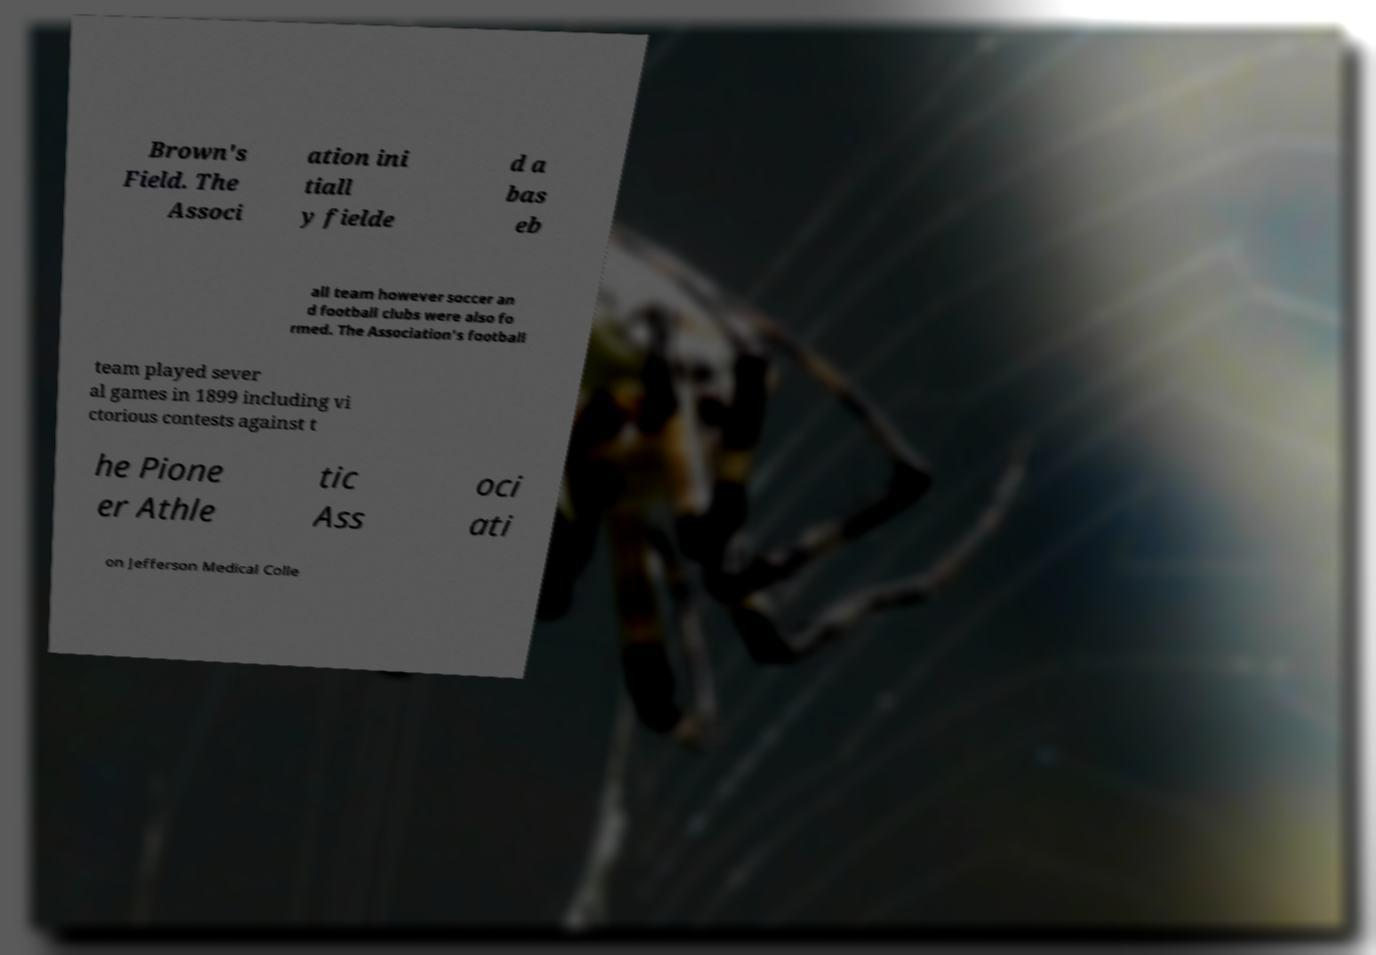Could you extract and type out the text from this image? Brown's Field. The Associ ation ini tiall y fielde d a bas eb all team however soccer an d football clubs were also fo rmed. The Association's football team played sever al games in 1899 including vi ctorious contests against t he Pione er Athle tic Ass oci ati on Jefferson Medical Colle 